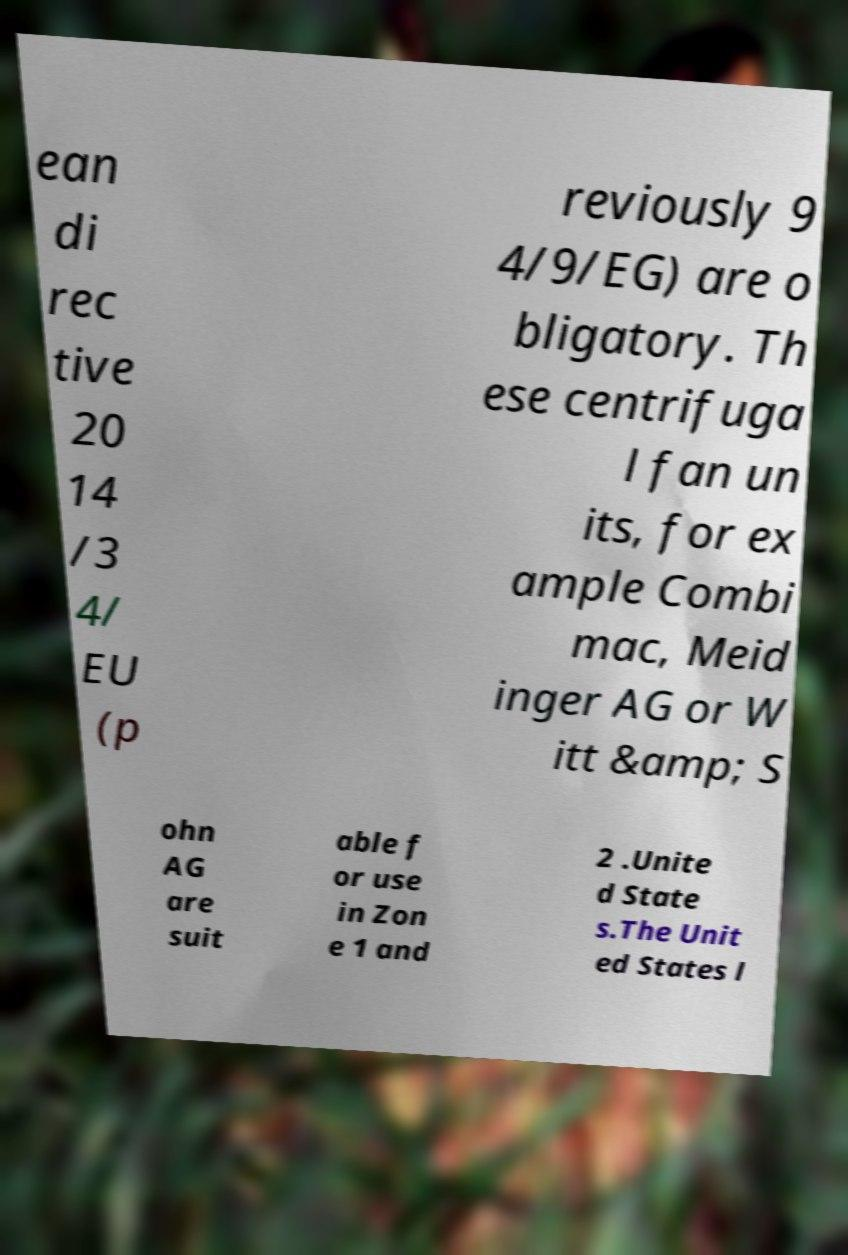Can you read and provide the text displayed in the image?This photo seems to have some interesting text. Can you extract and type it out for me? ean di rec tive 20 14 /3 4/ EU (p reviously 9 4/9/EG) are o bligatory. Th ese centrifuga l fan un its, for ex ample Combi mac, Meid inger AG or W itt &amp; S ohn AG are suit able f or use in Zon e 1 and 2 .Unite d State s.The Unit ed States l 